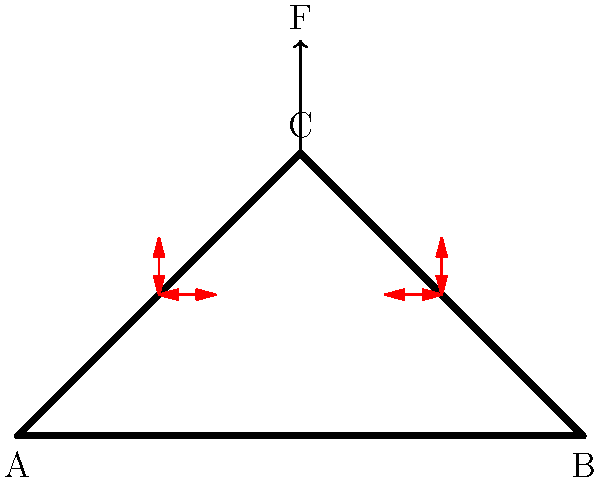In the historical truss bridge structure shown above, a vertical force F is applied at point C. Assuming the bridge is symmetrical and the material is homogeneous, which member of the bridge experiences the highest compressive stress? To determine which member experiences the highest compressive stress, we need to analyze the force distribution in the bridge structure:

1. The vertical force F at point C is distributed equally between the two diagonal members (AC and BC) due to the symmetry of the structure.

2. The diagonal members (AC and BC) experience both axial and bending stresses. The axial component is compressive, pushing these members towards points A and B.

3. The horizontal member (AB) experiences tension as it resists the outward push of the diagonal members.

4. The compressive stress in the diagonal members can be calculated using the formula:
   $$\sigma = \frac{F}{2A \cos\theta}$$
   where $\sigma$ is the stress, $F$ is the applied force, $A$ is the cross-sectional area of the member, and $\theta$ is the angle between the diagonal member and the horizontal.

5. The angle $\theta$ is less than 90°, so $\cos\theta$ will be less than 1, increasing the stress in the diagonal members compared to a vertical member of the same cross-sectional area.

6. The horizontal member (AB) experiences only axial tension, which is generally lower in magnitude than the compressive stress in the diagonal members.

Therefore, the diagonal members (AC and BC) experience the highest compressive stress in this bridge structure.
Answer: Diagonal members (AC and BC) 